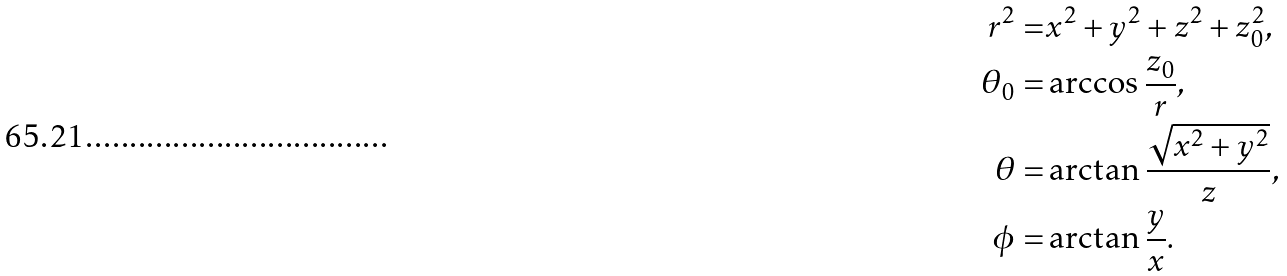Convert formula to latex. <formula><loc_0><loc_0><loc_500><loc_500>r ^ { 2 } = & x ^ { 2 } + y ^ { 2 } + z ^ { 2 } + z ^ { 2 } _ { 0 } , \\ \theta _ { 0 } = & \arccos \frac { z _ { 0 } } { r } , \\ \theta = & \arctan \frac { \sqrt { x ^ { 2 } + y ^ { 2 } } } { z } , \\ \phi = & \arctan \frac { y } { x } .</formula> 